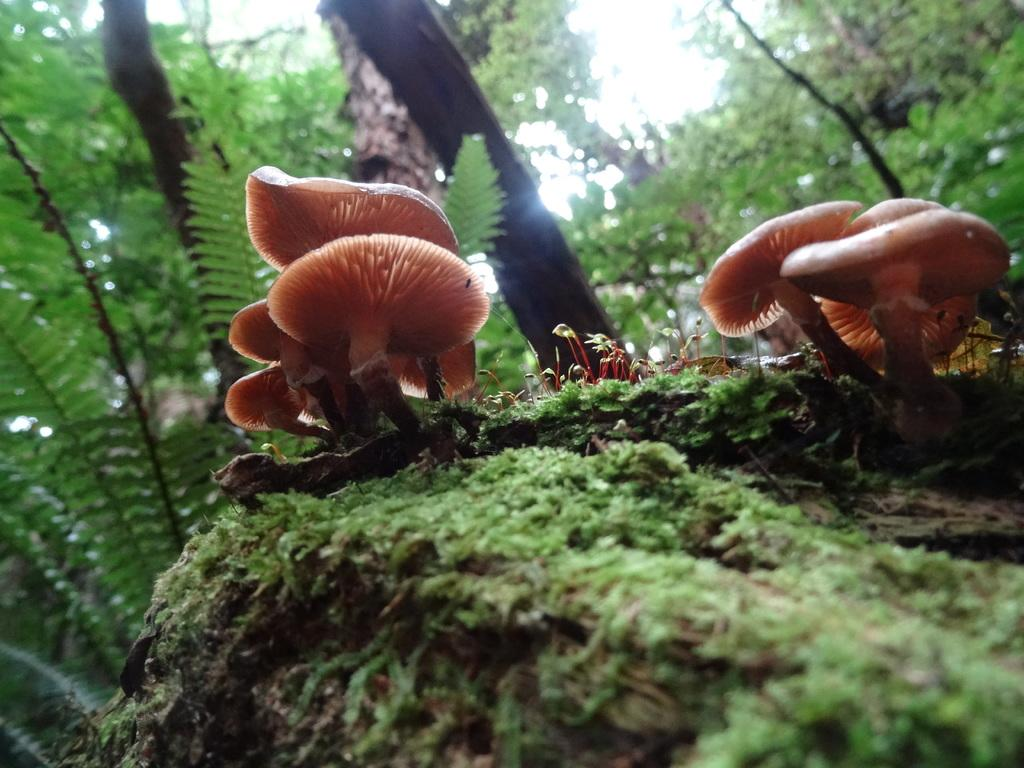What type of vegetation is present in the image? There are mushrooms, grass, and trees in the image. What can be seen beneath the vegetation in the image? The ground is visible in the image. What is visible above the vegetation in the image? The sky is visible in the image. What type of farmer is shown tending to the mushrooms in the image? There is no farmer present in the image; it only features mushrooms, grass, trees, the ground, and the sky. What dish is being prepared for dinner using the mushrooms in the image? There is no indication of a dinner being prepared or any dish being made in the image. 